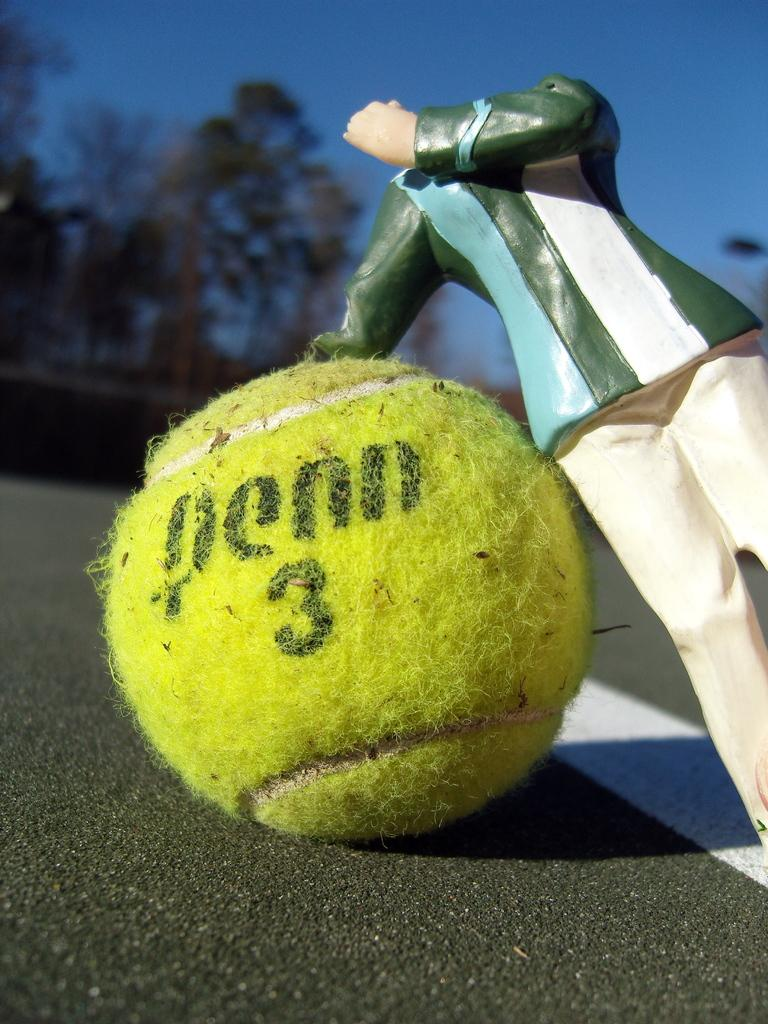<image>
Give a short and clear explanation of the subsequent image. A yellow tennis ball is on the road with the number 3 on it. 